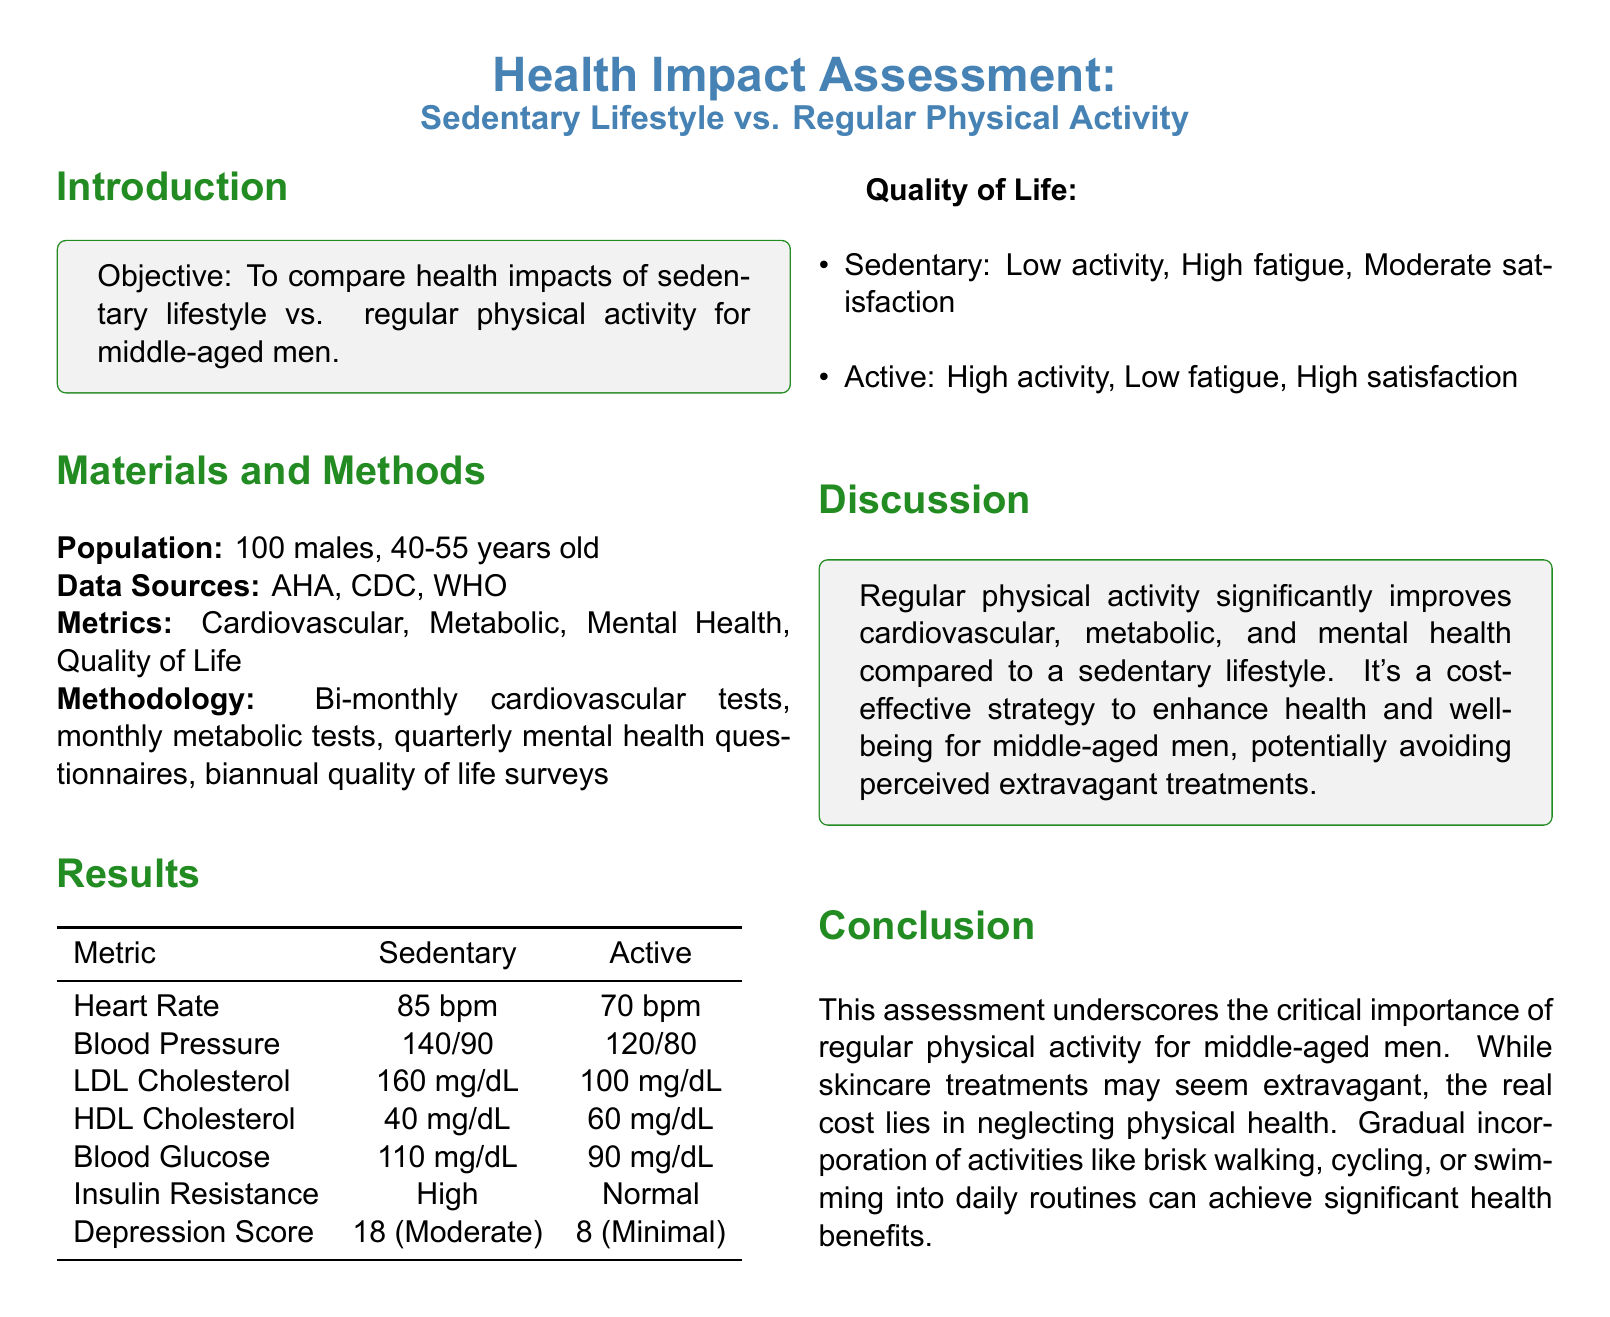What is the objective of the health impact assessment? The objective is to compare health impacts of sedentary lifestyle vs. regular physical activity for middle-aged men.
Answer: Compare health impacts of sedentary lifestyle vs. regular physical activity for middle-aged men What was the age range of the population studied? The age range of the studied population is mentioned as 40-55 years old.
Answer: 40-55 years old What was the blood pressure reading for the active group? The blood pressure reading for the active group is recorded in the results table.
Answer: 120/80 What was the LDL cholesterol level for the sedentary group? The LDL cholesterol level for the sedentary group can be found in the results table.
Answer: 160 mg/dL What is the depression score for the active group? The depression score for the active group is listed in the results section.
Answer: 8 (Minimal) What is one of the cardio metrics measured in the study? The document states several metrics measured, one of which can be cardiovascular metrics.
Answer: Heart Rate What conclusion is drawn regarding physical activity? The conclusion emphasizes the importance of regular physical activity for health improvement.
Answer: Regular physical activity significantly improves health What type of surveys were conducted biannually? The document outlines surveys pertaining to quality of life as being conducted biannually.
Answer: Quality of life surveys What was the score indicating the depression level in the sedentary group? The score indicating the depression level for the sedentary group can be found in the results section.
Answer: 18 (Moderate) 